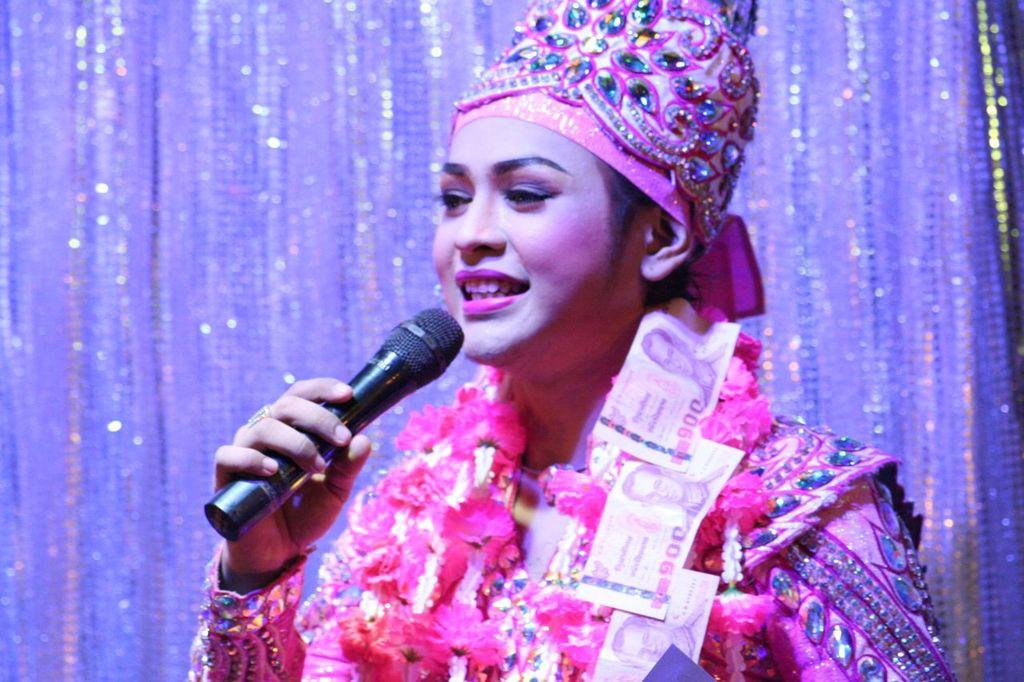Who is the main subject in the picture? There is a woman in the picture. What is the woman doing in the image? The woman is standing and speaking. What object is the woman holding in her hand? The woman is holding a microphone in her hand. What type of feather can be seen on the woman's hat in the image? There is no feather present on the woman's hat in the image. 